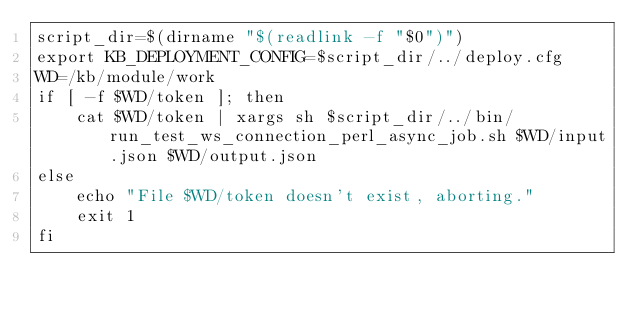Convert code to text. <code><loc_0><loc_0><loc_500><loc_500><_Bash_>script_dir=$(dirname "$(readlink -f "$0")")
export KB_DEPLOYMENT_CONFIG=$script_dir/../deploy.cfg
WD=/kb/module/work
if [ -f $WD/token ]; then
    cat $WD/token | xargs sh $script_dir/../bin/run_test_ws_connection_perl_async_job.sh $WD/input.json $WD/output.json
else
    echo "File $WD/token doesn't exist, aborting."
    exit 1
fi
</code> 